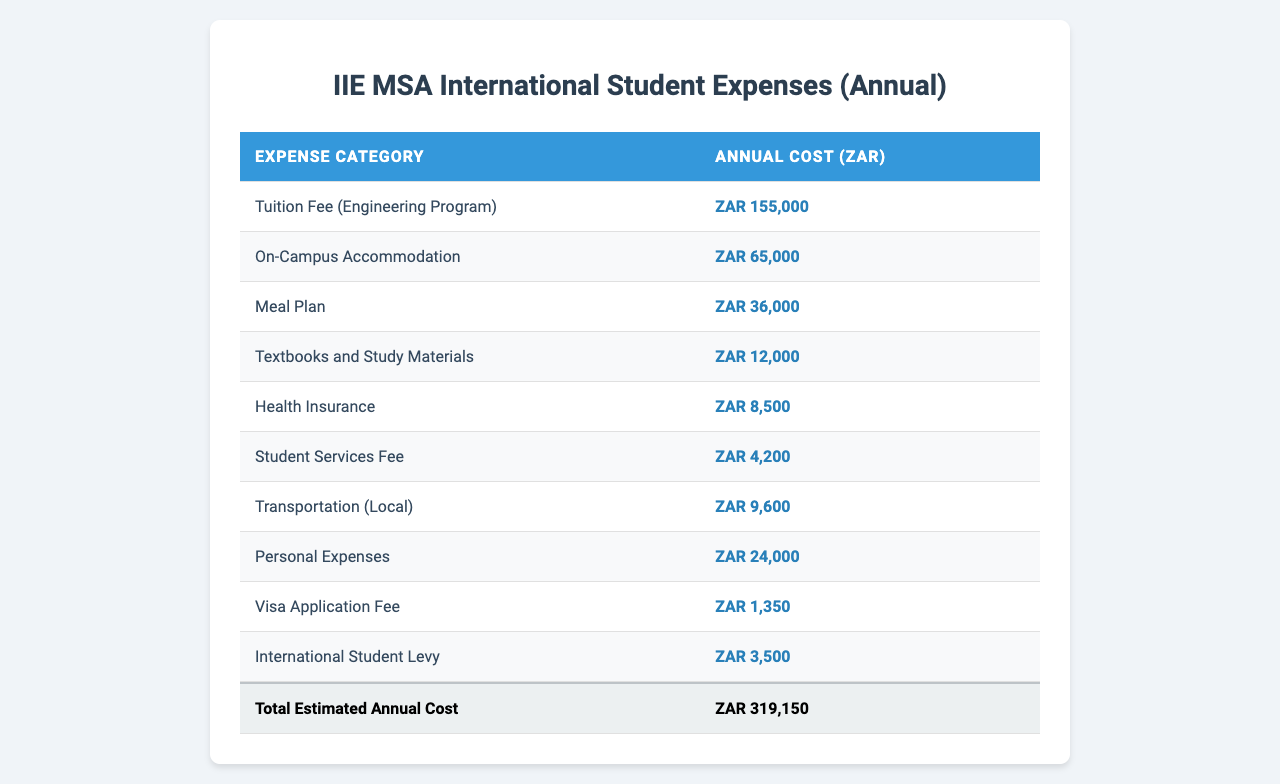What is the tuition fee for the engineering program at IIE MSA? The table lists the tuition fee under the "Expense Category" as "Tuition Fee (Engineering Program)" and the corresponding "Annual Cost (ZAR)" is 155,000.
Answer: 155,000 ZAR What is the total cost of living expenses (excluding tuition) for an international student? To find the total cost of living expenses, sum all the costs except for the tuition fee: 65,000 (Accommodation) + 36,000 (Meal Plan) + 12,000 (Textbooks) + 8,500 (Health Insurance) + 4,200 (Student Services) + 9,600 (Transportation) + 24,000 (Personal Expenses) + 1,350 (Visa Fee) + 3,500 (International Student Levy) = 164,150 ZAR.
Answer: 164,150 ZAR Is the cost of on-campus accommodation higher than the meal plan? The table lists on-campus accommodation at 65,000 ZAR and the meal plan at 36,000 ZAR. Since 65,000 is greater than 36,000, on-campus accommodation is indeed higher.
Answer: Yes What is the average annual cost of textbooks and study materials and meal plan combined? The cost of textbooks is 12,000 ZAR, and the meal plan is 36,000 ZAR. Adding them gives 12,000 + 36,000 = 48,000 ZAR. The average (since there are two items) is 48,000 / 2 = 24,000 ZAR.
Answer: 24,000 ZAR If a student spends 10,000 ZAR on personal expenses, what will their total expense be including tuition and all other living costs? The total expenses including tuition (155,000 ZAR), living expenses (164,150 ZAR), and personal expenses (10,000 ZAR) is calculated as follows: 155,000 + 164,150 + 10,000 = 329,150 ZAR.
Answer: 329,150 ZAR What is the total estimated annual cost for an international student at IIE MSA? The total estimated annual cost sums up all individual expenses displayed in the table: 155,000 (Tuition) + 65,000 (Accommodation) + 36,000 (Meal Plan) + 12,000 (Textbooks) + 8,500 (Health Insurance) + 4,200 (Student Services) + 9,600 (Transportation) + 24,000 (Personal Expenses) + 1,350 (Visa Fee) + 3,500 (International Student Levy) = 309,150 ZAR.
Answer: 309,150 ZAR How much will a student spend on health insurance per year? The table shows that the health insurance cost is listed separately as 8,500 ZAR.
Answer: 8,500 ZAR What is the difference in cost between the international student levy and the visa application fee? The international student levy is 3,500 ZAR and the visa application fee is 1,350 ZAR. The difference is 3,500 - 1,350 = 2,150 ZAR.
Answer: 2,150 ZAR Are total living expenses (excluding tuition) higher than the annual cost of health insurance? The total living expenses are 164,150 ZAR (as calculated earlier), while health insurance is listed as 8,500 ZAR. Since 164,150 is greater than 8,500, the statement is true.
Answer: Yes What percentage of the total estimated annual cost is attributed to the tuition fee? The tuition fee is 155,000 ZAR, and the total cost is 309,150 ZAR. To find the percentage, calculate (155,000 / 309,150) * 100 = 50.14%.
Answer: 50.14% 